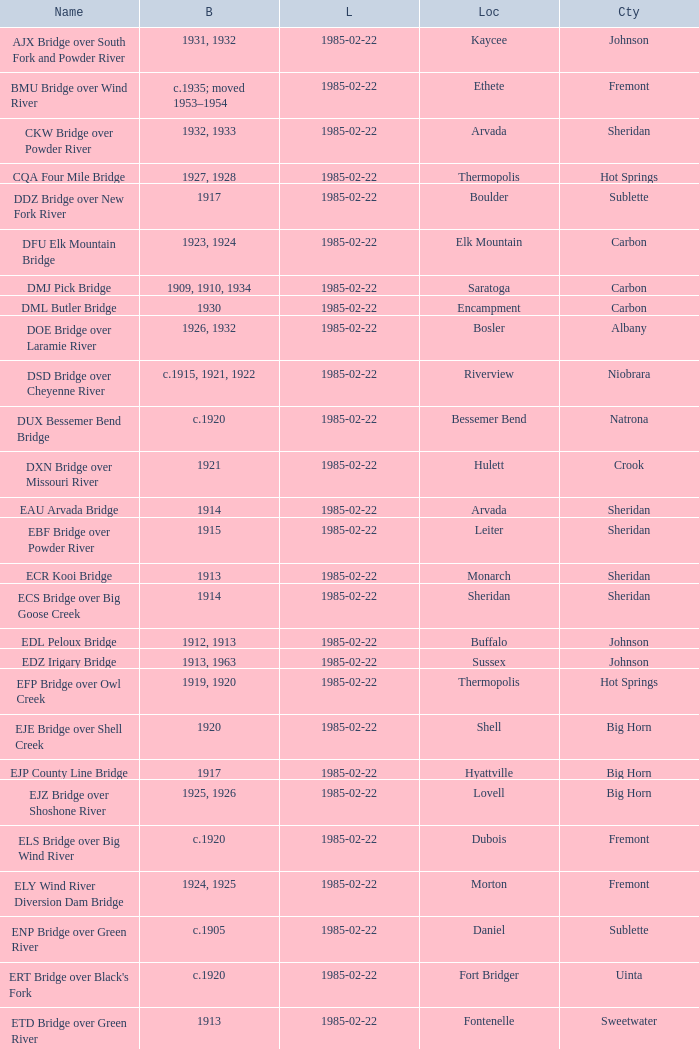What bridge in Sheridan county was built in 1915? EBF Bridge over Powder River. 